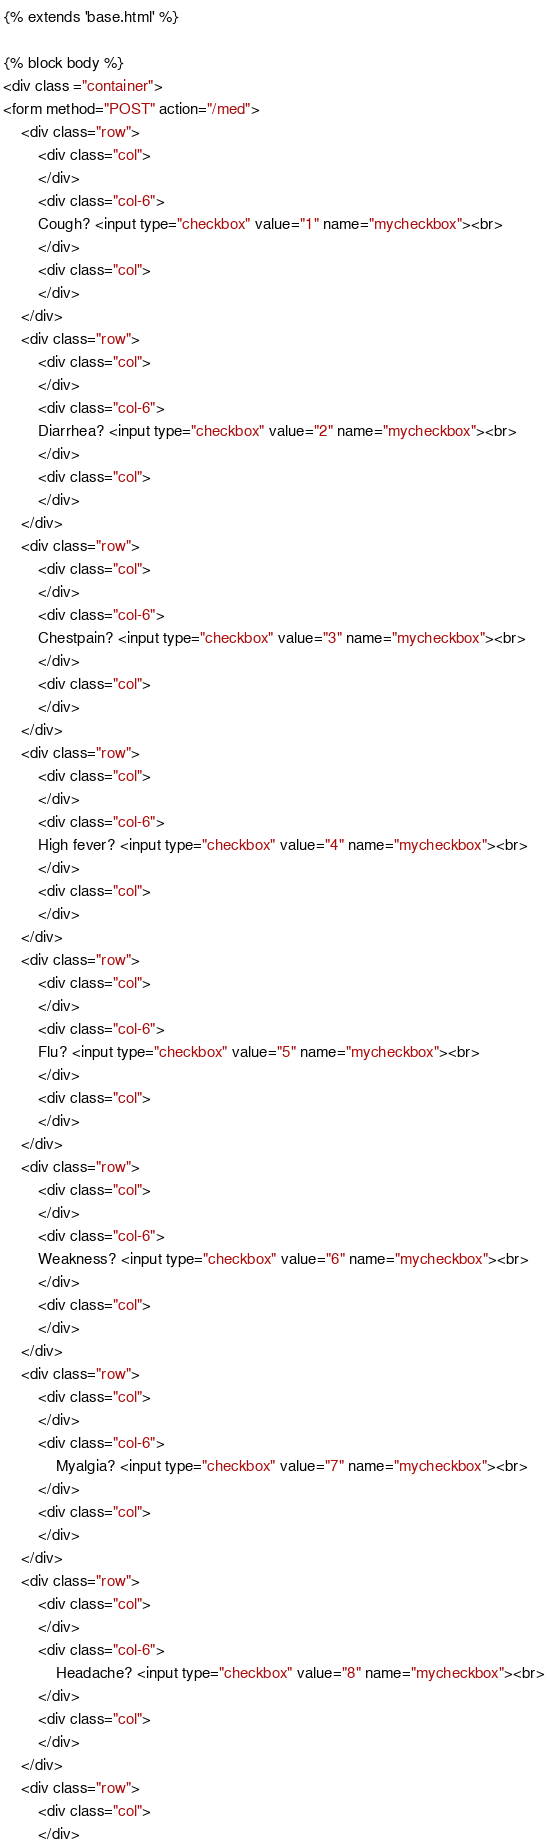Convert code to text. <code><loc_0><loc_0><loc_500><loc_500><_HTML_>{% extends 'base.html' %}

{% block body %}
<div class ="container">
<form method="POST" action="/med">
    <div class="row">
        <div class="col">
        </div>
        <div class="col-6">
        Cough? <input type="checkbox" value="1" name="mycheckbox"><br>
        </div>
        <div class="col">
        </div>
    </div>
    <div class="row">
        <div class="col">
        </div>
        <div class="col-6">
        Diarrhea? <input type="checkbox" value="2" name="mycheckbox"><br>
        </div>
        <div class="col">
        </div>
    </div>
    <div class="row">
        <div class="col">
        </div>
        <div class="col-6">
        Chestpain? <input type="checkbox" value="3" name="mycheckbox"><br>
        </div>
        <div class="col">
        </div>
    </div>
    <div class="row">
        <div class="col">
        </div>
        <div class="col-6">
        High fever? <input type="checkbox" value="4" name="mycheckbox"><br>
        </div>
        <div class="col">
        </div>
    </div>
    <div class="row">
        <div class="col">
        </div>
        <div class="col-6">
        Flu? <input type="checkbox" value="5" name="mycheckbox"><br>
        </div>
        <div class="col">
        </div>
    </div>
    <div class="row">
        <div class="col">
        </div>
        <div class="col-6">
        Weakness? <input type="checkbox" value="6" name="mycheckbox"><br>
        </div>
        <div class="col">
        </div>
    </div>
    <div class="row">
        <div class="col">
        </div>
        <div class="col-6">
            Myalgia? <input type="checkbox" value="7" name="mycheckbox"><br>
        </div>
        <div class="col">
        </div>
    </div>
    <div class="row">
        <div class="col">
        </div>
        <div class="col-6">
            Headache? <input type="checkbox" value="8" name="mycheckbox"><br>
        </div>
        <div class="col">
        </div>
    </div>
    <div class="row">
        <div class="col">
        </div></code> 